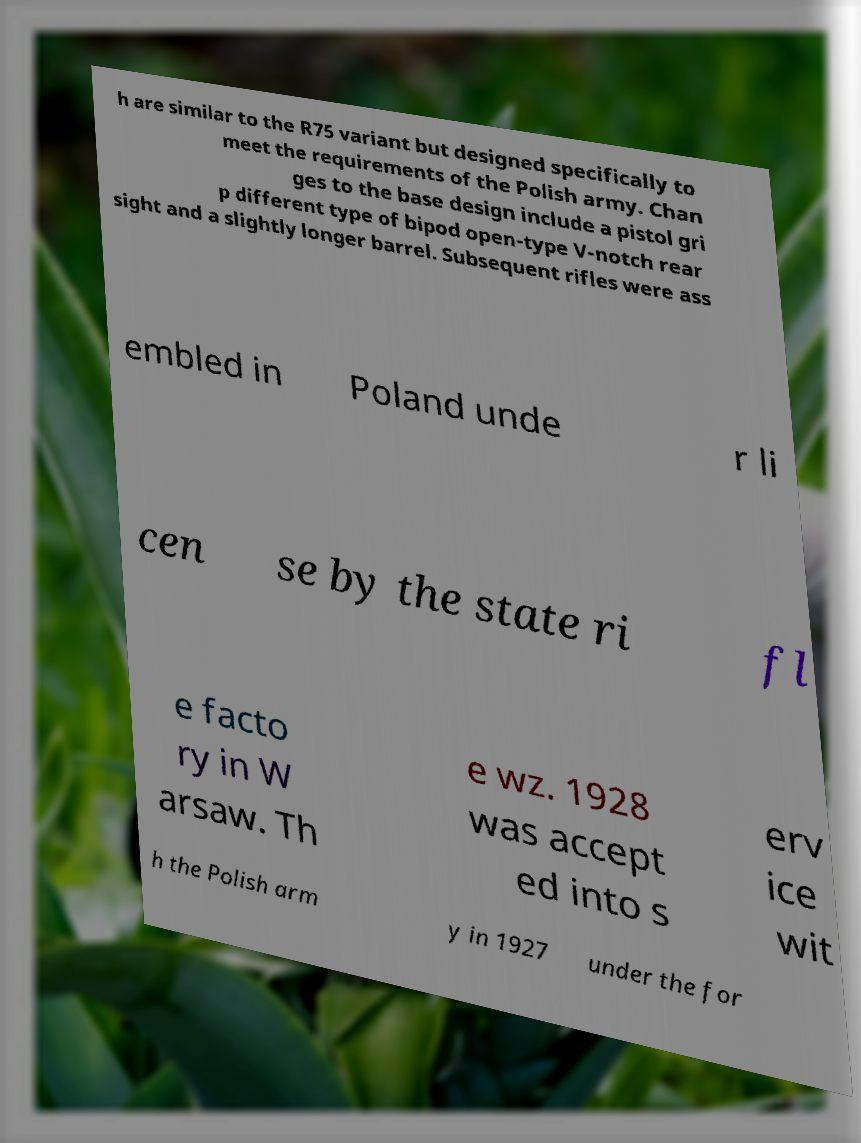There's text embedded in this image that I need extracted. Can you transcribe it verbatim? h are similar to the R75 variant but designed specifically to meet the requirements of the Polish army. Chan ges to the base design include a pistol gri p different type of bipod open-type V-notch rear sight and a slightly longer barrel. Subsequent rifles were ass embled in Poland unde r li cen se by the state ri fl e facto ry in W arsaw. Th e wz. 1928 was accept ed into s erv ice wit h the Polish arm y in 1927 under the for 